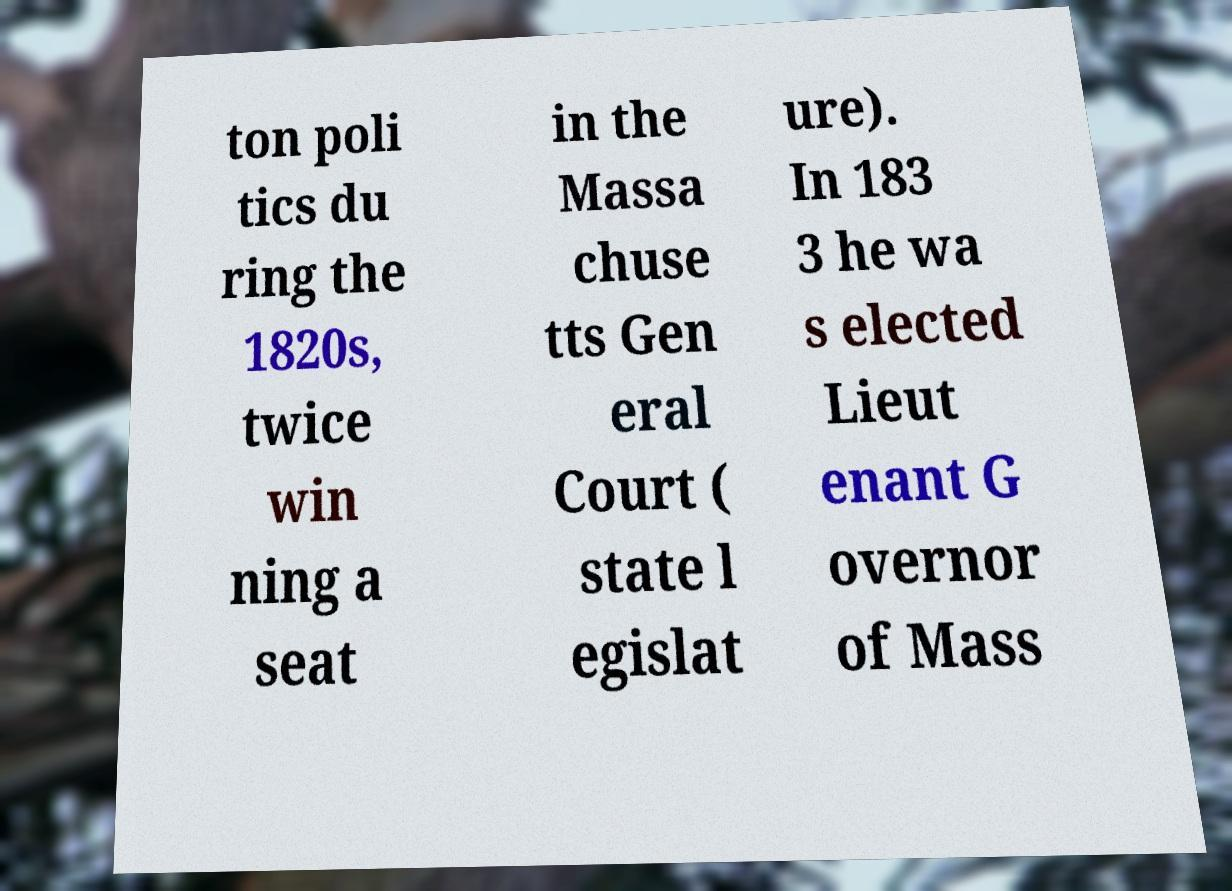Can you read and provide the text displayed in the image?This photo seems to have some interesting text. Can you extract and type it out for me? ton poli tics du ring the 1820s, twice win ning a seat in the Massa chuse tts Gen eral Court ( state l egislat ure). In 183 3 he wa s elected Lieut enant G overnor of Mass 